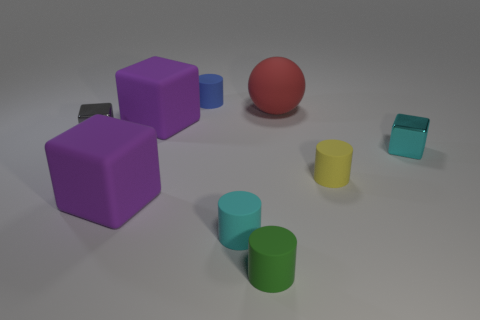There is a tiny yellow matte thing; does it have the same shape as the tiny shiny thing that is to the left of the small blue thing?
Make the answer very short. No. What number of gray metal things have the same shape as the big red rubber object?
Provide a short and direct response. 0. The blue rubber thing is what shape?
Ensure brevity in your answer.  Cylinder. There is a shiny object that is right of the tiny metallic block left of the big sphere; what size is it?
Your answer should be very brief. Small. How many things are either large matte things or small gray metallic objects?
Keep it short and to the point. 4. Does the tiny blue rubber thing have the same shape as the gray thing?
Offer a very short reply. No. Are there any purple blocks that have the same material as the green cylinder?
Provide a short and direct response. Yes. There is a tiny block to the right of the red matte thing; is there a rubber thing behind it?
Your response must be concise. Yes. Do the purple matte cube that is in front of the yellow cylinder and the small green cylinder have the same size?
Provide a short and direct response. No. What size is the green rubber object?
Your answer should be compact. Small. 